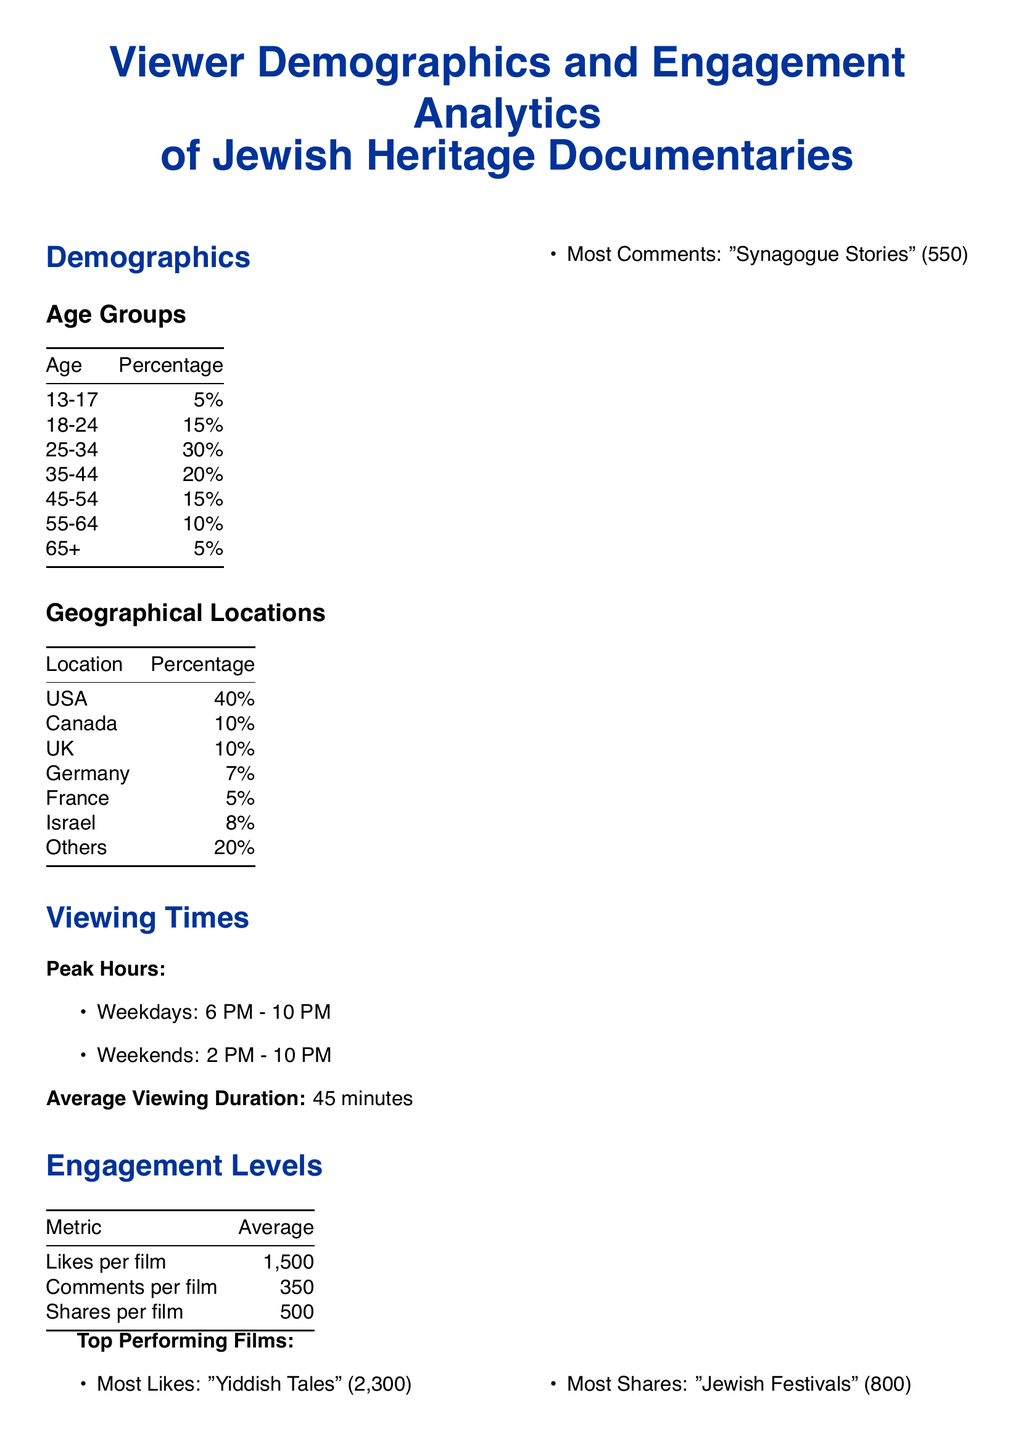What is the percentage of viewers aged 18-24? This data is available in the demographics section under age groups, which states that 15% of viewers are in the 18-24 age group.
Answer: 15% What is the average viewing duration for Jewish Heritage Documentaries? The document specifies that the average viewing duration is 45 minutes.
Answer: 45 minutes Which country has the highest percentage of viewers? The demographics section shows that the USA has the highest percentage, at 40%.
Answer: USA What was the attendance for the New York Jewish Film Festival? The document lists the attendance for this event as 1,500 in the screening events table.
Answer: 1,500 What is the average number of shares per film? The engagement levels section indicates that the average number of shares per film is 500.
Answer: 500 Which film received the most likes? The top performing films itemizes that "Yiddish Tales" received the most likes, totaling 2,300.
Answer: "Yiddish Tales" What are the peak viewing hours during weekends? The document lists peak viewing hours for weekends as 2 PM - 10 PM.
Answer: 2 PM - 10 PM How many likes does the film "Jewish Festivals" have? The top performing films section states that "Jewish Festivals" has 800 likes.
Answer: 800 What is the average number of comments per film? According to the engagement levels table, the average number of comments per film is 350.
Answer: 350 